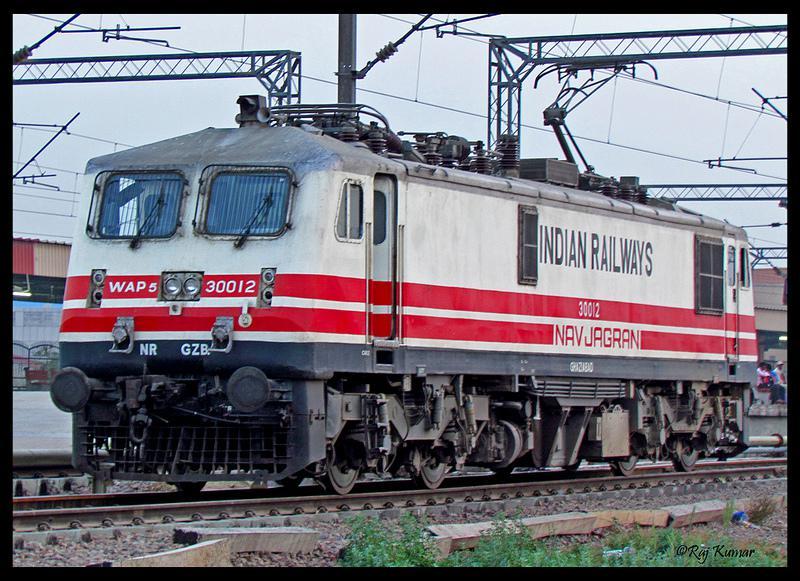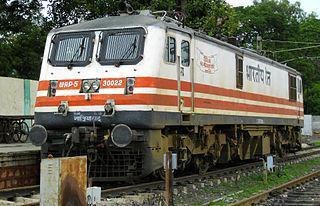The first image is the image on the left, the second image is the image on the right. For the images shown, is this caption "Exactly two trains are angled in the same direction." true? Answer yes or no. Yes. The first image is the image on the left, the second image is the image on the right. Assess this claim about the two images: "The train in the image on the right has at least one full length red stripe.". Correct or not? Answer yes or no. Yes. 